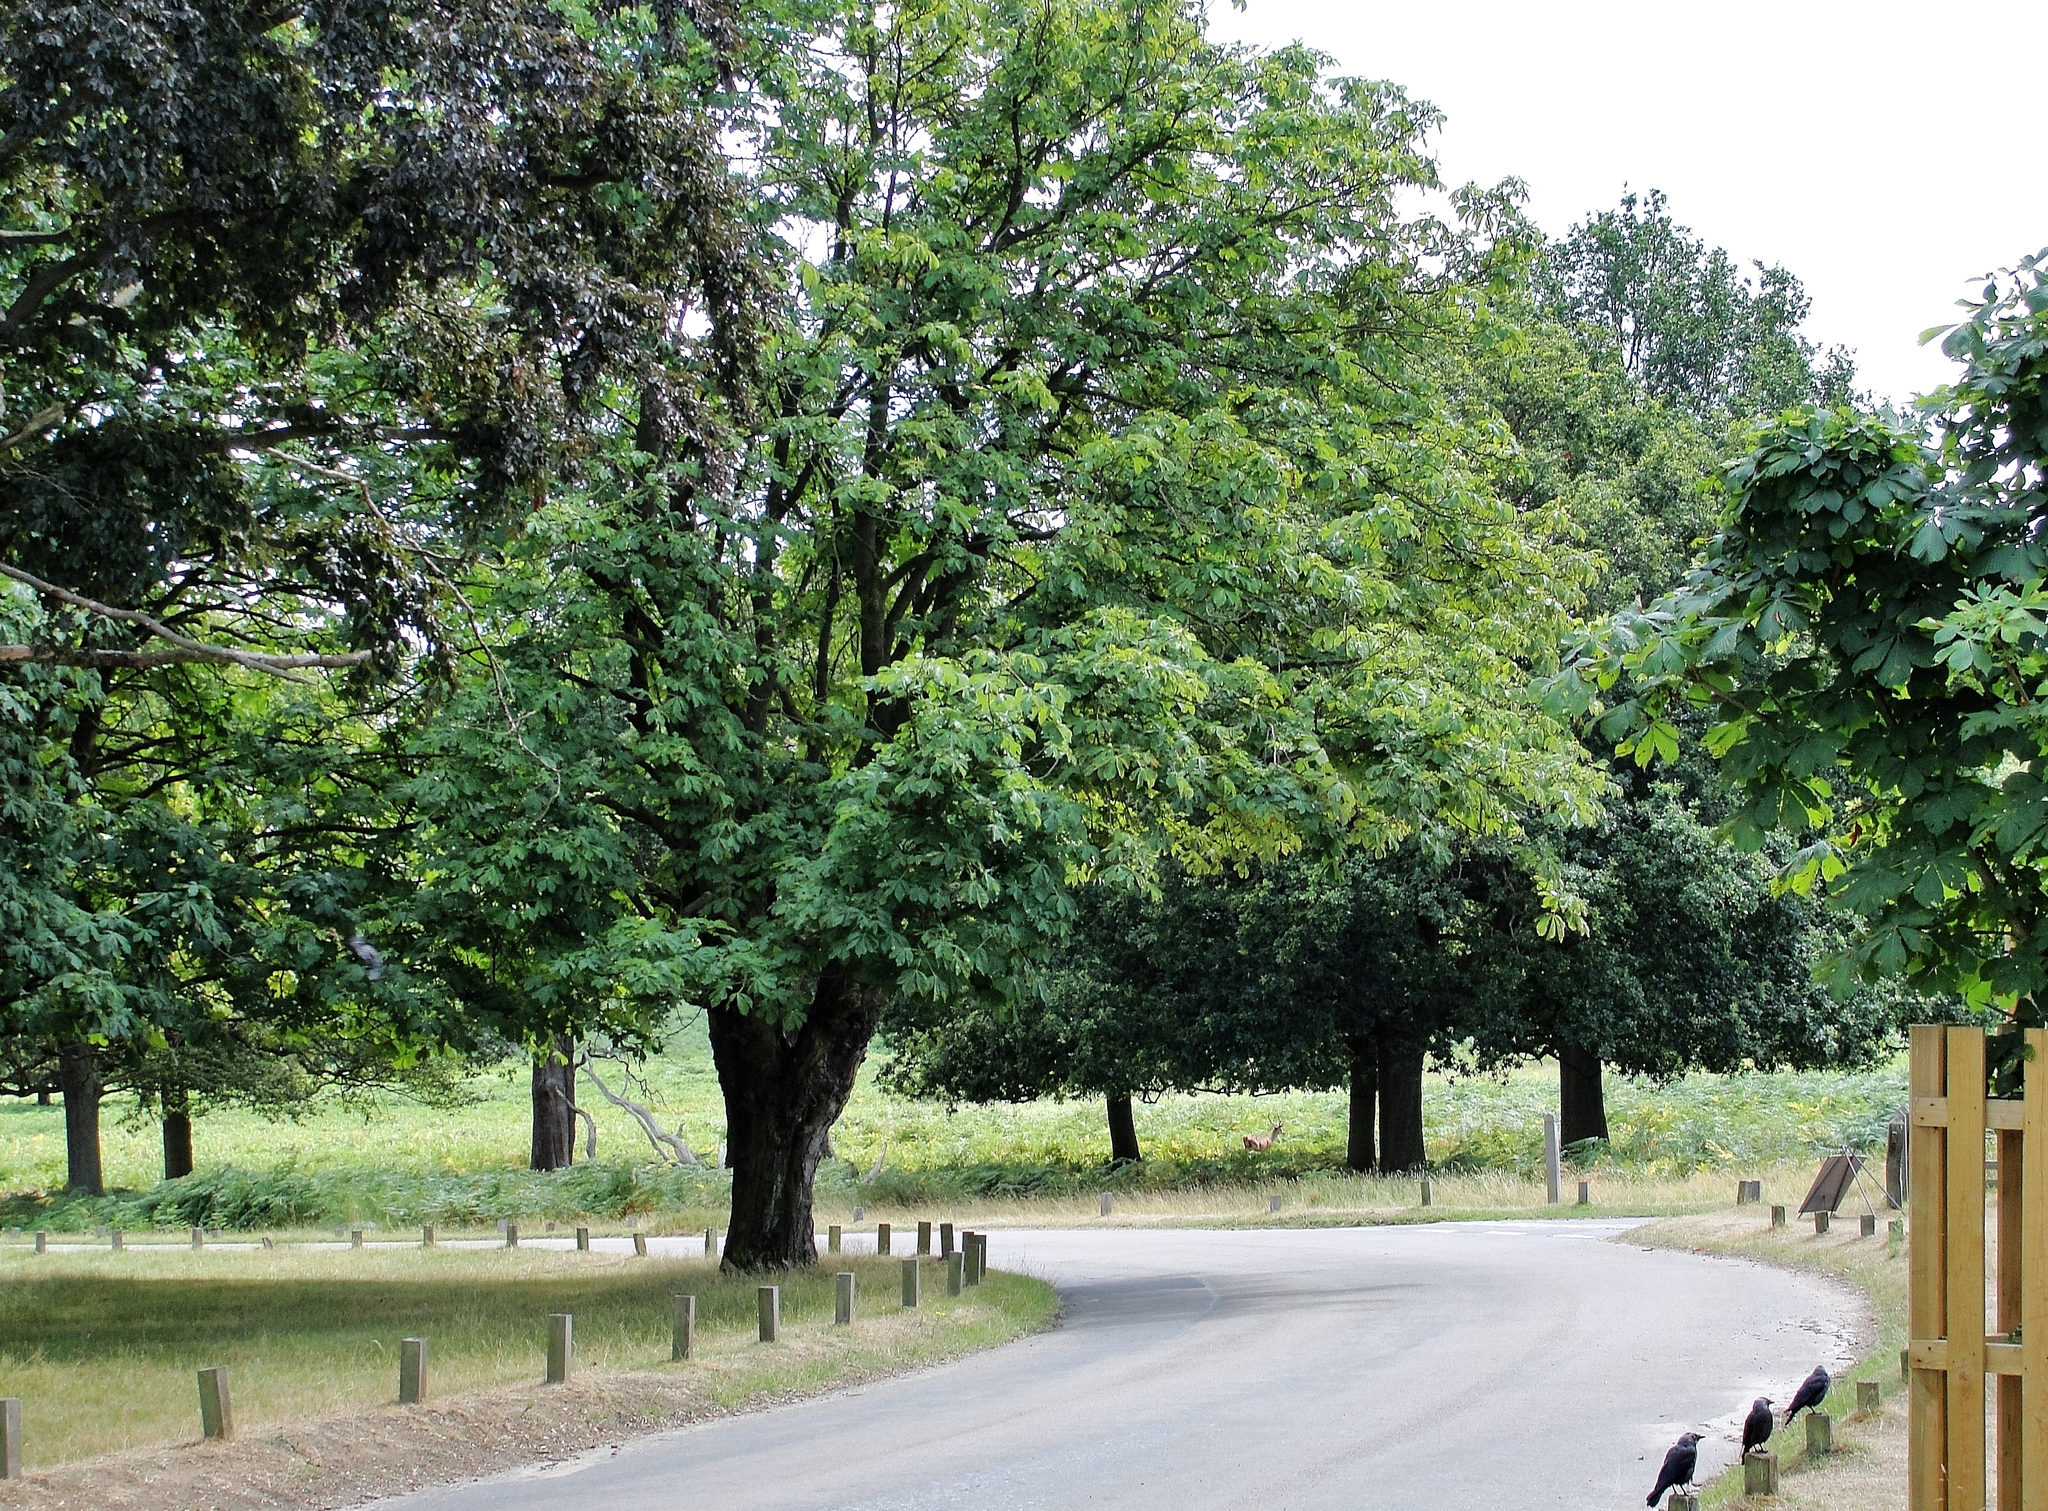Could you give a brief overview of what you see in this image? In this image we can see a road. On the sides of the road there are small poles. On the poles there are few birds sitting. Also there are trees. In the back there are trees. On the right side there is a wooden stand. 